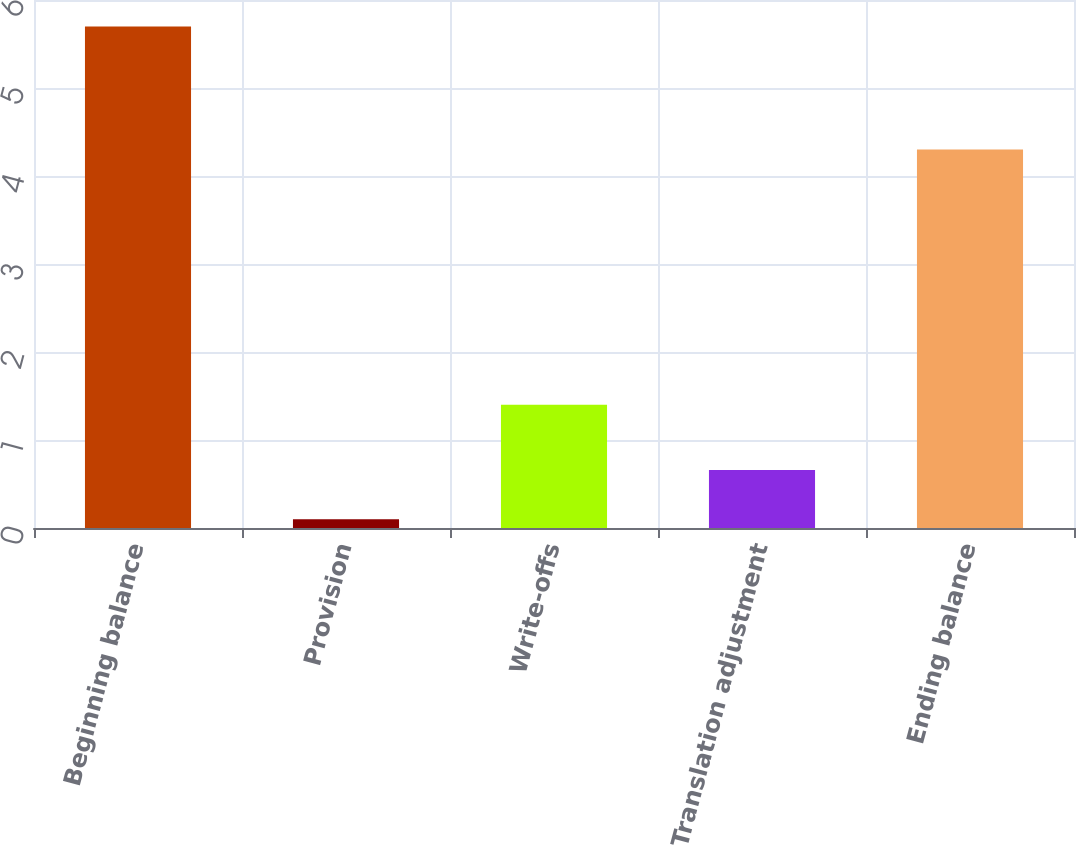Convert chart. <chart><loc_0><loc_0><loc_500><loc_500><bar_chart><fcel>Beginning balance<fcel>Provision<fcel>Write-offs<fcel>Translation adjustment<fcel>Ending balance<nl><fcel>5.7<fcel>0.1<fcel>1.4<fcel>0.66<fcel>4.3<nl></chart> 